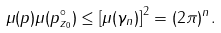Convert formula to latex. <formula><loc_0><loc_0><loc_500><loc_500>\mu ( p ) \mu ( p _ { z _ { 0 } } ^ { \circ } ) \leq \left [ \mu ( \gamma _ { n } ) \right ] ^ { 2 } = ( 2 \pi ) ^ { n } .</formula> 